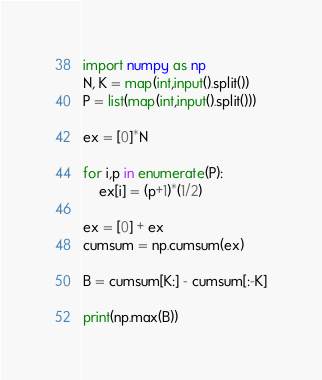Convert code to text. <code><loc_0><loc_0><loc_500><loc_500><_Python_>import numpy as np
N, K = map(int,input().split())
P = list(map(int,input().split()))

ex = [0]*N

for i,p in enumerate(P):
    ex[i] = (p+1)*(1/2)

ex = [0] + ex
cumsum = np.cumsum(ex)

B = cumsum[K:] - cumsum[:-K]

print(np.max(B))</code> 